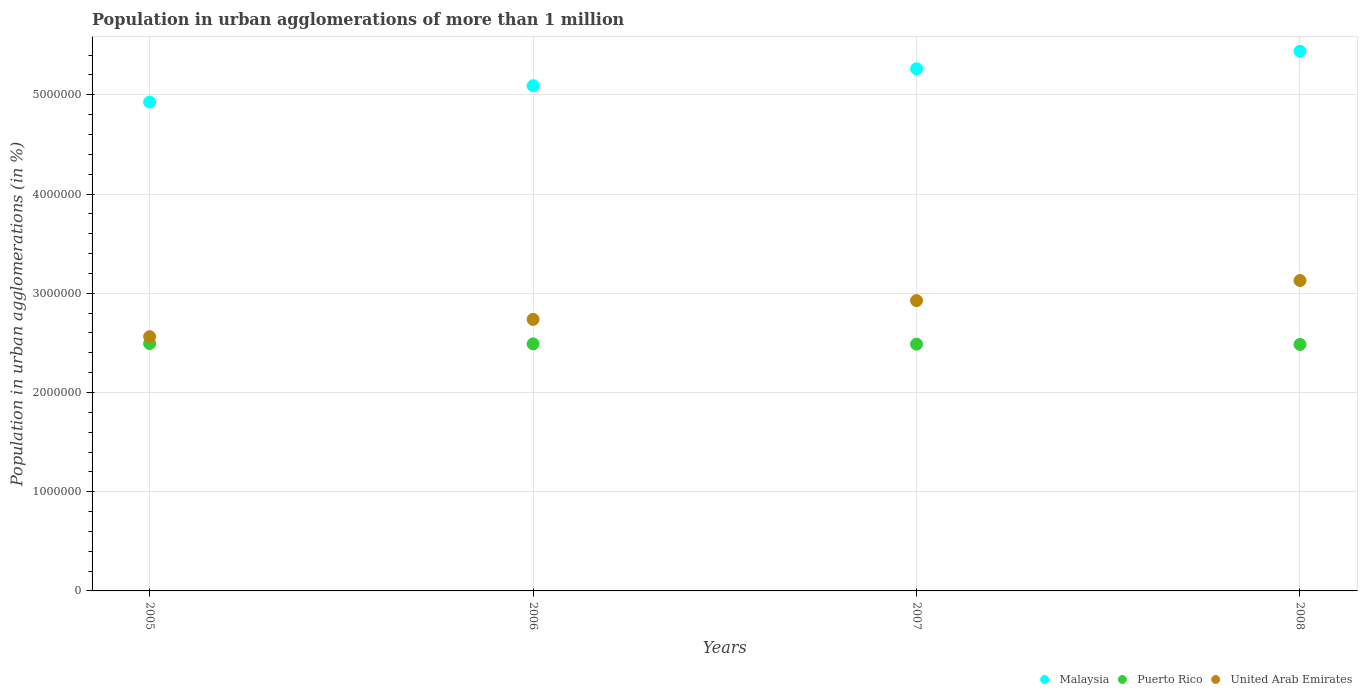How many different coloured dotlines are there?
Offer a very short reply. 3. What is the population in urban agglomerations in United Arab Emirates in 2007?
Provide a short and direct response. 2.93e+06. Across all years, what is the maximum population in urban agglomerations in United Arab Emirates?
Provide a succinct answer. 3.13e+06. Across all years, what is the minimum population in urban agglomerations in United Arab Emirates?
Keep it short and to the point. 2.56e+06. In which year was the population in urban agglomerations in United Arab Emirates maximum?
Offer a terse response. 2008. In which year was the population in urban agglomerations in United Arab Emirates minimum?
Your answer should be compact. 2005. What is the total population in urban agglomerations in United Arab Emirates in the graph?
Your response must be concise. 1.14e+07. What is the difference between the population in urban agglomerations in Puerto Rico in 2006 and that in 2008?
Your answer should be very brief. 6009. What is the difference between the population in urban agglomerations in Puerto Rico in 2006 and the population in urban agglomerations in United Arab Emirates in 2005?
Give a very brief answer. -7.23e+04. What is the average population in urban agglomerations in Malaysia per year?
Your answer should be very brief. 5.18e+06. In the year 2007, what is the difference between the population in urban agglomerations in Puerto Rico and population in urban agglomerations in United Arab Emirates?
Offer a very short reply. -4.39e+05. In how many years, is the population in urban agglomerations in United Arab Emirates greater than 2800000 %?
Provide a short and direct response. 2. What is the ratio of the population in urban agglomerations in Puerto Rico in 2005 to that in 2006?
Provide a succinct answer. 1. Is the difference between the population in urban agglomerations in Puerto Rico in 2005 and 2008 greater than the difference between the population in urban agglomerations in United Arab Emirates in 2005 and 2008?
Keep it short and to the point. Yes. What is the difference between the highest and the second highest population in urban agglomerations in Malaysia?
Your answer should be very brief. 1.77e+05. What is the difference between the highest and the lowest population in urban agglomerations in United Arab Emirates?
Keep it short and to the point. 5.66e+05. Is the sum of the population in urban agglomerations in United Arab Emirates in 2005 and 2007 greater than the maximum population in urban agglomerations in Malaysia across all years?
Your answer should be very brief. Yes. How many years are there in the graph?
Your answer should be compact. 4. What is the difference between two consecutive major ticks on the Y-axis?
Offer a terse response. 1.00e+06. Are the values on the major ticks of Y-axis written in scientific E-notation?
Give a very brief answer. No. Does the graph contain any zero values?
Provide a short and direct response. No. Where does the legend appear in the graph?
Your answer should be compact. Bottom right. What is the title of the graph?
Provide a succinct answer. Population in urban agglomerations of more than 1 million. Does "Finland" appear as one of the legend labels in the graph?
Offer a terse response. No. What is the label or title of the X-axis?
Provide a succinct answer. Years. What is the label or title of the Y-axis?
Ensure brevity in your answer.  Population in urban agglomerations (in %). What is the Population in urban agglomerations (in %) of Malaysia in 2005?
Provide a succinct answer. 4.93e+06. What is the Population in urban agglomerations (in %) of Puerto Rico in 2005?
Make the answer very short. 2.49e+06. What is the Population in urban agglomerations (in %) of United Arab Emirates in 2005?
Your response must be concise. 2.56e+06. What is the Population in urban agglomerations (in %) of Malaysia in 2006?
Your answer should be compact. 5.09e+06. What is the Population in urban agglomerations (in %) in Puerto Rico in 2006?
Make the answer very short. 2.49e+06. What is the Population in urban agglomerations (in %) in United Arab Emirates in 2006?
Keep it short and to the point. 2.74e+06. What is the Population in urban agglomerations (in %) of Malaysia in 2007?
Make the answer very short. 5.26e+06. What is the Population in urban agglomerations (in %) of Puerto Rico in 2007?
Offer a terse response. 2.49e+06. What is the Population in urban agglomerations (in %) of United Arab Emirates in 2007?
Your answer should be very brief. 2.93e+06. What is the Population in urban agglomerations (in %) in Malaysia in 2008?
Give a very brief answer. 5.44e+06. What is the Population in urban agglomerations (in %) of Puerto Rico in 2008?
Keep it short and to the point. 2.48e+06. What is the Population in urban agglomerations (in %) of United Arab Emirates in 2008?
Provide a short and direct response. 3.13e+06. Across all years, what is the maximum Population in urban agglomerations (in %) of Malaysia?
Your response must be concise. 5.44e+06. Across all years, what is the maximum Population in urban agglomerations (in %) of Puerto Rico?
Keep it short and to the point. 2.49e+06. Across all years, what is the maximum Population in urban agglomerations (in %) in United Arab Emirates?
Offer a terse response. 3.13e+06. Across all years, what is the minimum Population in urban agglomerations (in %) of Malaysia?
Offer a terse response. 4.93e+06. Across all years, what is the minimum Population in urban agglomerations (in %) of Puerto Rico?
Your answer should be very brief. 2.48e+06. Across all years, what is the minimum Population in urban agglomerations (in %) in United Arab Emirates?
Provide a short and direct response. 2.56e+06. What is the total Population in urban agglomerations (in %) of Malaysia in the graph?
Your answer should be very brief. 2.07e+07. What is the total Population in urban agglomerations (in %) of Puerto Rico in the graph?
Your answer should be very brief. 9.95e+06. What is the total Population in urban agglomerations (in %) in United Arab Emirates in the graph?
Make the answer very short. 1.14e+07. What is the difference between the Population in urban agglomerations (in %) in Malaysia in 2005 and that in 2006?
Make the answer very short. -1.65e+05. What is the difference between the Population in urban agglomerations (in %) of Puerto Rico in 2005 and that in 2006?
Provide a short and direct response. 3008. What is the difference between the Population in urban agglomerations (in %) of United Arab Emirates in 2005 and that in 2006?
Your answer should be very brief. -1.74e+05. What is the difference between the Population in urban agglomerations (in %) in Malaysia in 2005 and that in 2007?
Provide a short and direct response. -3.36e+05. What is the difference between the Population in urban agglomerations (in %) in Puerto Rico in 2005 and that in 2007?
Keep it short and to the point. 6012. What is the difference between the Population in urban agglomerations (in %) of United Arab Emirates in 2005 and that in 2007?
Make the answer very short. -3.64e+05. What is the difference between the Population in urban agglomerations (in %) of Malaysia in 2005 and that in 2008?
Give a very brief answer. -5.13e+05. What is the difference between the Population in urban agglomerations (in %) in Puerto Rico in 2005 and that in 2008?
Keep it short and to the point. 9017. What is the difference between the Population in urban agglomerations (in %) of United Arab Emirates in 2005 and that in 2008?
Your answer should be compact. -5.66e+05. What is the difference between the Population in urban agglomerations (in %) in Malaysia in 2006 and that in 2007?
Provide a succinct answer. -1.71e+05. What is the difference between the Population in urban agglomerations (in %) of Puerto Rico in 2006 and that in 2007?
Offer a very short reply. 3004. What is the difference between the Population in urban agglomerations (in %) of United Arab Emirates in 2006 and that in 2007?
Make the answer very short. -1.89e+05. What is the difference between the Population in urban agglomerations (in %) in Malaysia in 2006 and that in 2008?
Your response must be concise. -3.47e+05. What is the difference between the Population in urban agglomerations (in %) of Puerto Rico in 2006 and that in 2008?
Keep it short and to the point. 6009. What is the difference between the Population in urban agglomerations (in %) of United Arab Emirates in 2006 and that in 2008?
Give a very brief answer. -3.92e+05. What is the difference between the Population in urban agglomerations (in %) in Malaysia in 2007 and that in 2008?
Ensure brevity in your answer.  -1.77e+05. What is the difference between the Population in urban agglomerations (in %) of Puerto Rico in 2007 and that in 2008?
Make the answer very short. 3005. What is the difference between the Population in urban agglomerations (in %) in United Arab Emirates in 2007 and that in 2008?
Your answer should be very brief. -2.03e+05. What is the difference between the Population in urban agglomerations (in %) of Malaysia in 2005 and the Population in urban agglomerations (in %) of Puerto Rico in 2006?
Offer a terse response. 2.44e+06. What is the difference between the Population in urban agglomerations (in %) of Malaysia in 2005 and the Population in urban agglomerations (in %) of United Arab Emirates in 2006?
Offer a very short reply. 2.19e+06. What is the difference between the Population in urban agglomerations (in %) of Puerto Rico in 2005 and the Population in urban agglomerations (in %) of United Arab Emirates in 2006?
Keep it short and to the point. -2.44e+05. What is the difference between the Population in urban agglomerations (in %) in Malaysia in 2005 and the Population in urban agglomerations (in %) in Puerto Rico in 2007?
Give a very brief answer. 2.44e+06. What is the difference between the Population in urban agglomerations (in %) in Malaysia in 2005 and the Population in urban agglomerations (in %) in United Arab Emirates in 2007?
Keep it short and to the point. 2.00e+06. What is the difference between the Population in urban agglomerations (in %) in Puerto Rico in 2005 and the Population in urban agglomerations (in %) in United Arab Emirates in 2007?
Ensure brevity in your answer.  -4.33e+05. What is the difference between the Population in urban agglomerations (in %) of Malaysia in 2005 and the Population in urban agglomerations (in %) of Puerto Rico in 2008?
Your answer should be very brief. 2.44e+06. What is the difference between the Population in urban agglomerations (in %) in Malaysia in 2005 and the Population in urban agglomerations (in %) in United Arab Emirates in 2008?
Provide a succinct answer. 1.80e+06. What is the difference between the Population in urban agglomerations (in %) in Puerto Rico in 2005 and the Population in urban agglomerations (in %) in United Arab Emirates in 2008?
Keep it short and to the point. -6.35e+05. What is the difference between the Population in urban agglomerations (in %) in Malaysia in 2006 and the Population in urban agglomerations (in %) in Puerto Rico in 2007?
Your answer should be compact. 2.60e+06. What is the difference between the Population in urban agglomerations (in %) in Malaysia in 2006 and the Population in urban agglomerations (in %) in United Arab Emirates in 2007?
Offer a very short reply. 2.17e+06. What is the difference between the Population in urban agglomerations (in %) of Puerto Rico in 2006 and the Population in urban agglomerations (in %) of United Arab Emirates in 2007?
Your answer should be very brief. -4.36e+05. What is the difference between the Population in urban agglomerations (in %) in Malaysia in 2006 and the Population in urban agglomerations (in %) in Puerto Rico in 2008?
Make the answer very short. 2.61e+06. What is the difference between the Population in urban agglomerations (in %) in Malaysia in 2006 and the Population in urban agglomerations (in %) in United Arab Emirates in 2008?
Your response must be concise. 1.96e+06. What is the difference between the Population in urban agglomerations (in %) in Puerto Rico in 2006 and the Population in urban agglomerations (in %) in United Arab Emirates in 2008?
Your answer should be very brief. -6.38e+05. What is the difference between the Population in urban agglomerations (in %) of Malaysia in 2007 and the Population in urban agglomerations (in %) of Puerto Rico in 2008?
Your answer should be very brief. 2.78e+06. What is the difference between the Population in urban agglomerations (in %) of Malaysia in 2007 and the Population in urban agglomerations (in %) of United Arab Emirates in 2008?
Your answer should be compact. 2.13e+06. What is the difference between the Population in urban agglomerations (in %) in Puerto Rico in 2007 and the Population in urban agglomerations (in %) in United Arab Emirates in 2008?
Your answer should be compact. -6.41e+05. What is the average Population in urban agglomerations (in %) in Malaysia per year?
Your answer should be very brief. 5.18e+06. What is the average Population in urban agglomerations (in %) in Puerto Rico per year?
Provide a succinct answer. 2.49e+06. What is the average Population in urban agglomerations (in %) in United Arab Emirates per year?
Make the answer very short. 2.84e+06. In the year 2005, what is the difference between the Population in urban agglomerations (in %) in Malaysia and Population in urban agglomerations (in %) in Puerto Rico?
Your answer should be compact. 2.43e+06. In the year 2005, what is the difference between the Population in urban agglomerations (in %) in Malaysia and Population in urban agglomerations (in %) in United Arab Emirates?
Offer a terse response. 2.36e+06. In the year 2005, what is the difference between the Population in urban agglomerations (in %) in Puerto Rico and Population in urban agglomerations (in %) in United Arab Emirates?
Your answer should be very brief. -6.92e+04. In the year 2006, what is the difference between the Population in urban agglomerations (in %) of Malaysia and Population in urban agglomerations (in %) of Puerto Rico?
Keep it short and to the point. 2.60e+06. In the year 2006, what is the difference between the Population in urban agglomerations (in %) in Malaysia and Population in urban agglomerations (in %) in United Arab Emirates?
Provide a succinct answer. 2.36e+06. In the year 2006, what is the difference between the Population in urban agglomerations (in %) of Puerto Rico and Population in urban agglomerations (in %) of United Arab Emirates?
Your response must be concise. -2.47e+05. In the year 2007, what is the difference between the Population in urban agglomerations (in %) of Malaysia and Population in urban agglomerations (in %) of Puerto Rico?
Offer a terse response. 2.78e+06. In the year 2007, what is the difference between the Population in urban agglomerations (in %) in Malaysia and Population in urban agglomerations (in %) in United Arab Emirates?
Offer a terse response. 2.34e+06. In the year 2007, what is the difference between the Population in urban agglomerations (in %) of Puerto Rico and Population in urban agglomerations (in %) of United Arab Emirates?
Make the answer very short. -4.39e+05. In the year 2008, what is the difference between the Population in urban agglomerations (in %) in Malaysia and Population in urban agglomerations (in %) in Puerto Rico?
Provide a succinct answer. 2.96e+06. In the year 2008, what is the difference between the Population in urban agglomerations (in %) in Malaysia and Population in urban agglomerations (in %) in United Arab Emirates?
Provide a succinct answer. 2.31e+06. In the year 2008, what is the difference between the Population in urban agglomerations (in %) in Puerto Rico and Population in urban agglomerations (in %) in United Arab Emirates?
Your answer should be compact. -6.44e+05. What is the ratio of the Population in urban agglomerations (in %) in Malaysia in 2005 to that in 2006?
Your answer should be very brief. 0.97. What is the ratio of the Population in urban agglomerations (in %) in Puerto Rico in 2005 to that in 2006?
Give a very brief answer. 1. What is the ratio of the Population in urban agglomerations (in %) in United Arab Emirates in 2005 to that in 2006?
Give a very brief answer. 0.94. What is the ratio of the Population in urban agglomerations (in %) in Malaysia in 2005 to that in 2007?
Offer a terse response. 0.94. What is the ratio of the Population in urban agglomerations (in %) of Puerto Rico in 2005 to that in 2007?
Your answer should be compact. 1. What is the ratio of the Population in urban agglomerations (in %) of United Arab Emirates in 2005 to that in 2007?
Your answer should be very brief. 0.88. What is the ratio of the Population in urban agglomerations (in %) of Malaysia in 2005 to that in 2008?
Make the answer very short. 0.91. What is the ratio of the Population in urban agglomerations (in %) of Puerto Rico in 2005 to that in 2008?
Your response must be concise. 1. What is the ratio of the Population in urban agglomerations (in %) of United Arab Emirates in 2005 to that in 2008?
Provide a succinct answer. 0.82. What is the ratio of the Population in urban agglomerations (in %) of Malaysia in 2006 to that in 2007?
Keep it short and to the point. 0.97. What is the ratio of the Population in urban agglomerations (in %) of United Arab Emirates in 2006 to that in 2007?
Your answer should be very brief. 0.94. What is the ratio of the Population in urban agglomerations (in %) in Malaysia in 2006 to that in 2008?
Offer a very short reply. 0.94. What is the ratio of the Population in urban agglomerations (in %) in United Arab Emirates in 2006 to that in 2008?
Offer a terse response. 0.87. What is the ratio of the Population in urban agglomerations (in %) of Malaysia in 2007 to that in 2008?
Give a very brief answer. 0.97. What is the ratio of the Population in urban agglomerations (in %) in United Arab Emirates in 2007 to that in 2008?
Keep it short and to the point. 0.94. What is the difference between the highest and the second highest Population in urban agglomerations (in %) in Malaysia?
Your response must be concise. 1.77e+05. What is the difference between the highest and the second highest Population in urban agglomerations (in %) of Puerto Rico?
Make the answer very short. 3008. What is the difference between the highest and the second highest Population in urban agglomerations (in %) in United Arab Emirates?
Your answer should be compact. 2.03e+05. What is the difference between the highest and the lowest Population in urban agglomerations (in %) of Malaysia?
Keep it short and to the point. 5.13e+05. What is the difference between the highest and the lowest Population in urban agglomerations (in %) of Puerto Rico?
Your response must be concise. 9017. What is the difference between the highest and the lowest Population in urban agglomerations (in %) in United Arab Emirates?
Your answer should be compact. 5.66e+05. 